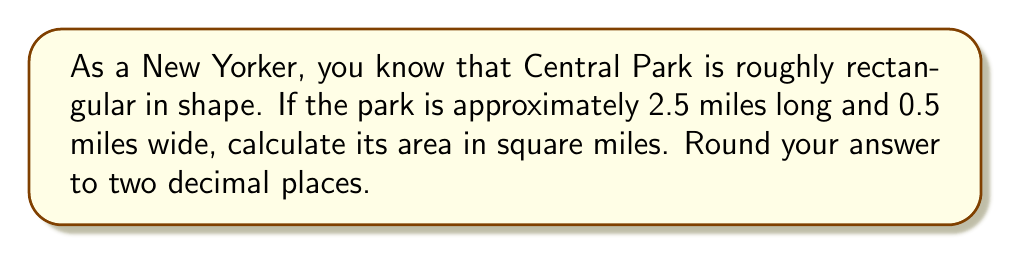Help me with this question. To calculate the area of Central Park using geometric shapes, we'll treat it as a rectangle. The formula for the area of a rectangle is:

$$A = l \times w$$

Where:
$A$ = area
$l$ = length
$w$ = width

Given:
- Length of Central Park: 2.5 miles
- Width of Central Park: 0.5 miles

Let's plug these values into our formula:

$$A = 2.5 \times 0.5$$

$$A = 1.25 \text{ square miles}$$

Since we're asked to round to two decimal places, our final answer is 1.25 square miles.

[asy]
unitsize(1cm);
draw((0,0)--(5,0)--(5,1)--(0,1)--cycle);
label("2.5 miles", (2.5,-0.5));
label("0.5 miles", (5.5,0.5));
label("Central Park", (2.5,0.5));
[/asy]
Answer: 1.25 square miles 